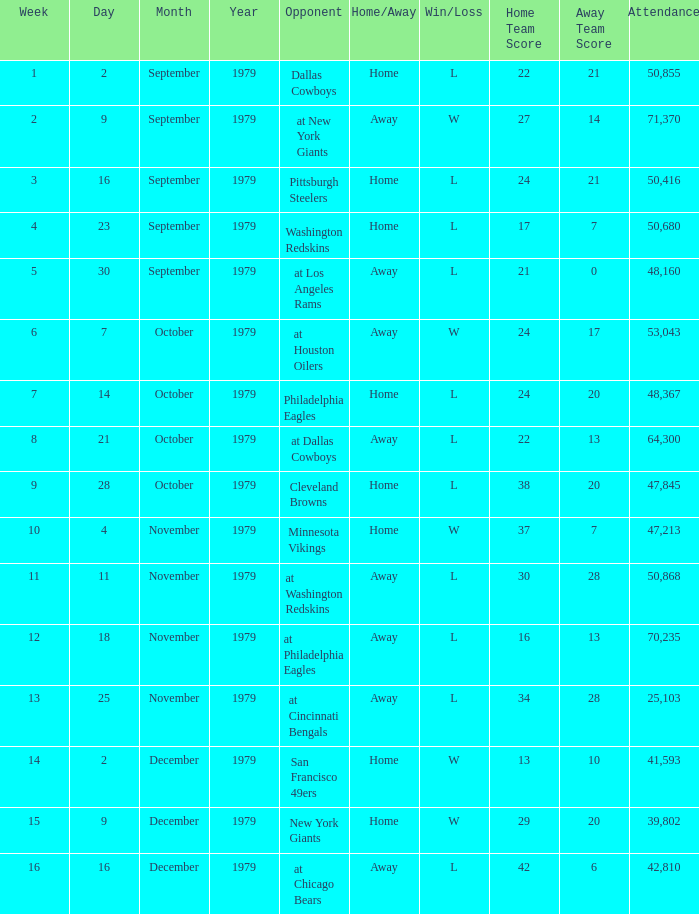What result in a week over 2 occurred with an attendance greater than 53,043 on November 18, 1979? L 16-13. 